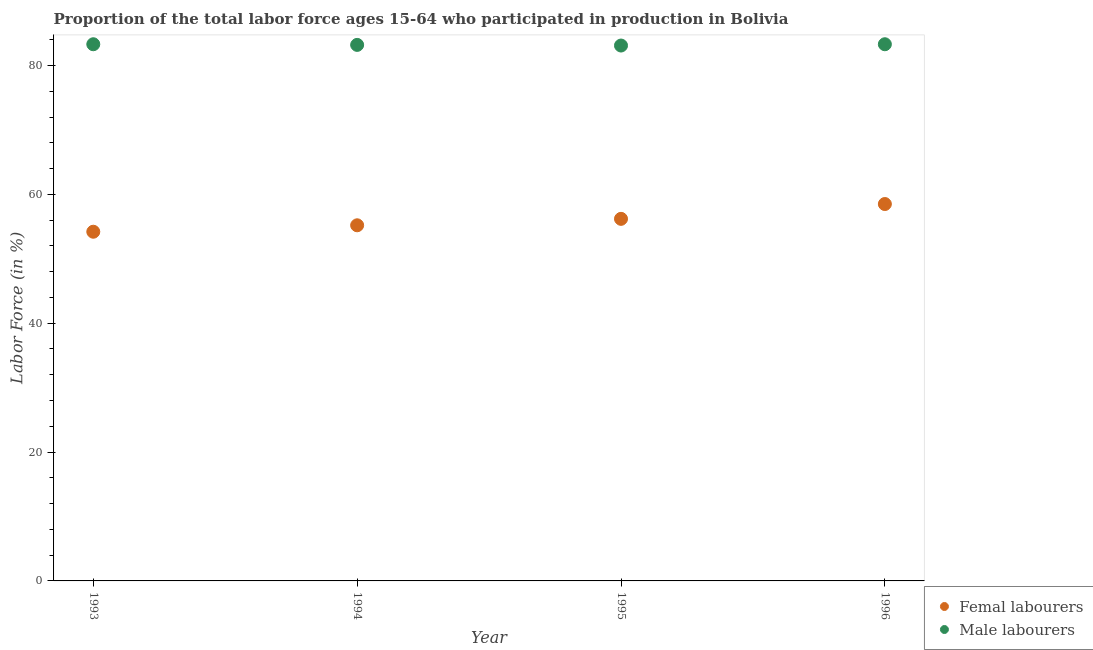Is the number of dotlines equal to the number of legend labels?
Your answer should be very brief. Yes. What is the percentage of female labor force in 1996?
Offer a very short reply. 58.5. Across all years, what is the maximum percentage of male labour force?
Provide a succinct answer. 83.3. Across all years, what is the minimum percentage of female labor force?
Your response must be concise. 54.2. In which year was the percentage of female labor force maximum?
Make the answer very short. 1996. What is the total percentage of female labor force in the graph?
Offer a very short reply. 224.1. What is the difference between the percentage of male labour force in 1993 and that in 1996?
Keep it short and to the point. 0. What is the difference between the percentage of female labor force in 1993 and the percentage of male labour force in 1996?
Provide a short and direct response. -29.1. What is the average percentage of female labor force per year?
Provide a short and direct response. 56.03. In the year 1993, what is the difference between the percentage of male labour force and percentage of female labor force?
Offer a terse response. 29.1. What is the ratio of the percentage of female labor force in 1993 to that in 1996?
Offer a very short reply. 0.93. What is the difference between the highest and the second highest percentage of male labour force?
Offer a very short reply. 0. What is the difference between the highest and the lowest percentage of male labour force?
Keep it short and to the point. 0.2. How many dotlines are there?
Offer a very short reply. 2. What is the difference between two consecutive major ticks on the Y-axis?
Your response must be concise. 20. Are the values on the major ticks of Y-axis written in scientific E-notation?
Provide a short and direct response. No. How many legend labels are there?
Your answer should be compact. 2. How are the legend labels stacked?
Provide a short and direct response. Vertical. What is the title of the graph?
Your response must be concise. Proportion of the total labor force ages 15-64 who participated in production in Bolivia. Does "Residents" appear as one of the legend labels in the graph?
Give a very brief answer. No. What is the Labor Force (in %) in Femal labourers in 1993?
Offer a terse response. 54.2. What is the Labor Force (in %) of Male labourers in 1993?
Keep it short and to the point. 83.3. What is the Labor Force (in %) in Femal labourers in 1994?
Provide a succinct answer. 55.2. What is the Labor Force (in %) in Male labourers in 1994?
Your answer should be very brief. 83.2. What is the Labor Force (in %) of Femal labourers in 1995?
Ensure brevity in your answer.  56.2. What is the Labor Force (in %) of Male labourers in 1995?
Ensure brevity in your answer.  83.1. What is the Labor Force (in %) in Femal labourers in 1996?
Your response must be concise. 58.5. What is the Labor Force (in %) in Male labourers in 1996?
Offer a terse response. 83.3. Across all years, what is the maximum Labor Force (in %) of Femal labourers?
Your answer should be compact. 58.5. Across all years, what is the maximum Labor Force (in %) in Male labourers?
Your answer should be very brief. 83.3. Across all years, what is the minimum Labor Force (in %) in Femal labourers?
Your response must be concise. 54.2. Across all years, what is the minimum Labor Force (in %) of Male labourers?
Your answer should be very brief. 83.1. What is the total Labor Force (in %) of Femal labourers in the graph?
Your response must be concise. 224.1. What is the total Labor Force (in %) of Male labourers in the graph?
Offer a terse response. 332.9. What is the difference between the Labor Force (in %) in Male labourers in 1993 and that in 1994?
Offer a very short reply. 0.1. What is the difference between the Labor Force (in %) in Male labourers in 1993 and that in 1995?
Your answer should be very brief. 0.2. What is the difference between the Labor Force (in %) of Femal labourers in 1994 and that in 1995?
Give a very brief answer. -1. What is the difference between the Labor Force (in %) of Male labourers in 1994 and that in 1995?
Provide a succinct answer. 0.1. What is the difference between the Labor Force (in %) of Femal labourers in 1995 and that in 1996?
Provide a short and direct response. -2.3. What is the difference between the Labor Force (in %) of Femal labourers in 1993 and the Labor Force (in %) of Male labourers in 1994?
Make the answer very short. -29. What is the difference between the Labor Force (in %) in Femal labourers in 1993 and the Labor Force (in %) in Male labourers in 1995?
Keep it short and to the point. -28.9. What is the difference between the Labor Force (in %) of Femal labourers in 1993 and the Labor Force (in %) of Male labourers in 1996?
Offer a very short reply. -29.1. What is the difference between the Labor Force (in %) in Femal labourers in 1994 and the Labor Force (in %) in Male labourers in 1995?
Provide a short and direct response. -27.9. What is the difference between the Labor Force (in %) in Femal labourers in 1994 and the Labor Force (in %) in Male labourers in 1996?
Provide a short and direct response. -28.1. What is the difference between the Labor Force (in %) of Femal labourers in 1995 and the Labor Force (in %) of Male labourers in 1996?
Provide a succinct answer. -27.1. What is the average Labor Force (in %) of Femal labourers per year?
Ensure brevity in your answer.  56.02. What is the average Labor Force (in %) of Male labourers per year?
Your answer should be very brief. 83.22. In the year 1993, what is the difference between the Labor Force (in %) in Femal labourers and Labor Force (in %) in Male labourers?
Provide a short and direct response. -29.1. In the year 1994, what is the difference between the Labor Force (in %) of Femal labourers and Labor Force (in %) of Male labourers?
Offer a terse response. -28. In the year 1995, what is the difference between the Labor Force (in %) of Femal labourers and Labor Force (in %) of Male labourers?
Your answer should be compact. -26.9. In the year 1996, what is the difference between the Labor Force (in %) of Femal labourers and Labor Force (in %) of Male labourers?
Provide a short and direct response. -24.8. What is the ratio of the Labor Force (in %) in Femal labourers in 1993 to that in 1994?
Your answer should be compact. 0.98. What is the ratio of the Labor Force (in %) of Femal labourers in 1993 to that in 1995?
Your response must be concise. 0.96. What is the ratio of the Labor Force (in %) of Femal labourers in 1993 to that in 1996?
Provide a succinct answer. 0.93. What is the ratio of the Labor Force (in %) of Male labourers in 1993 to that in 1996?
Your answer should be very brief. 1. What is the ratio of the Labor Force (in %) of Femal labourers in 1994 to that in 1995?
Provide a short and direct response. 0.98. What is the ratio of the Labor Force (in %) of Femal labourers in 1994 to that in 1996?
Keep it short and to the point. 0.94. What is the ratio of the Labor Force (in %) of Male labourers in 1994 to that in 1996?
Your response must be concise. 1. What is the ratio of the Labor Force (in %) of Femal labourers in 1995 to that in 1996?
Provide a succinct answer. 0.96. What is the ratio of the Labor Force (in %) of Male labourers in 1995 to that in 1996?
Offer a terse response. 1. What is the difference between the highest and the second highest Labor Force (in %) in Male labourers?
Give a very brief answer. 0. 